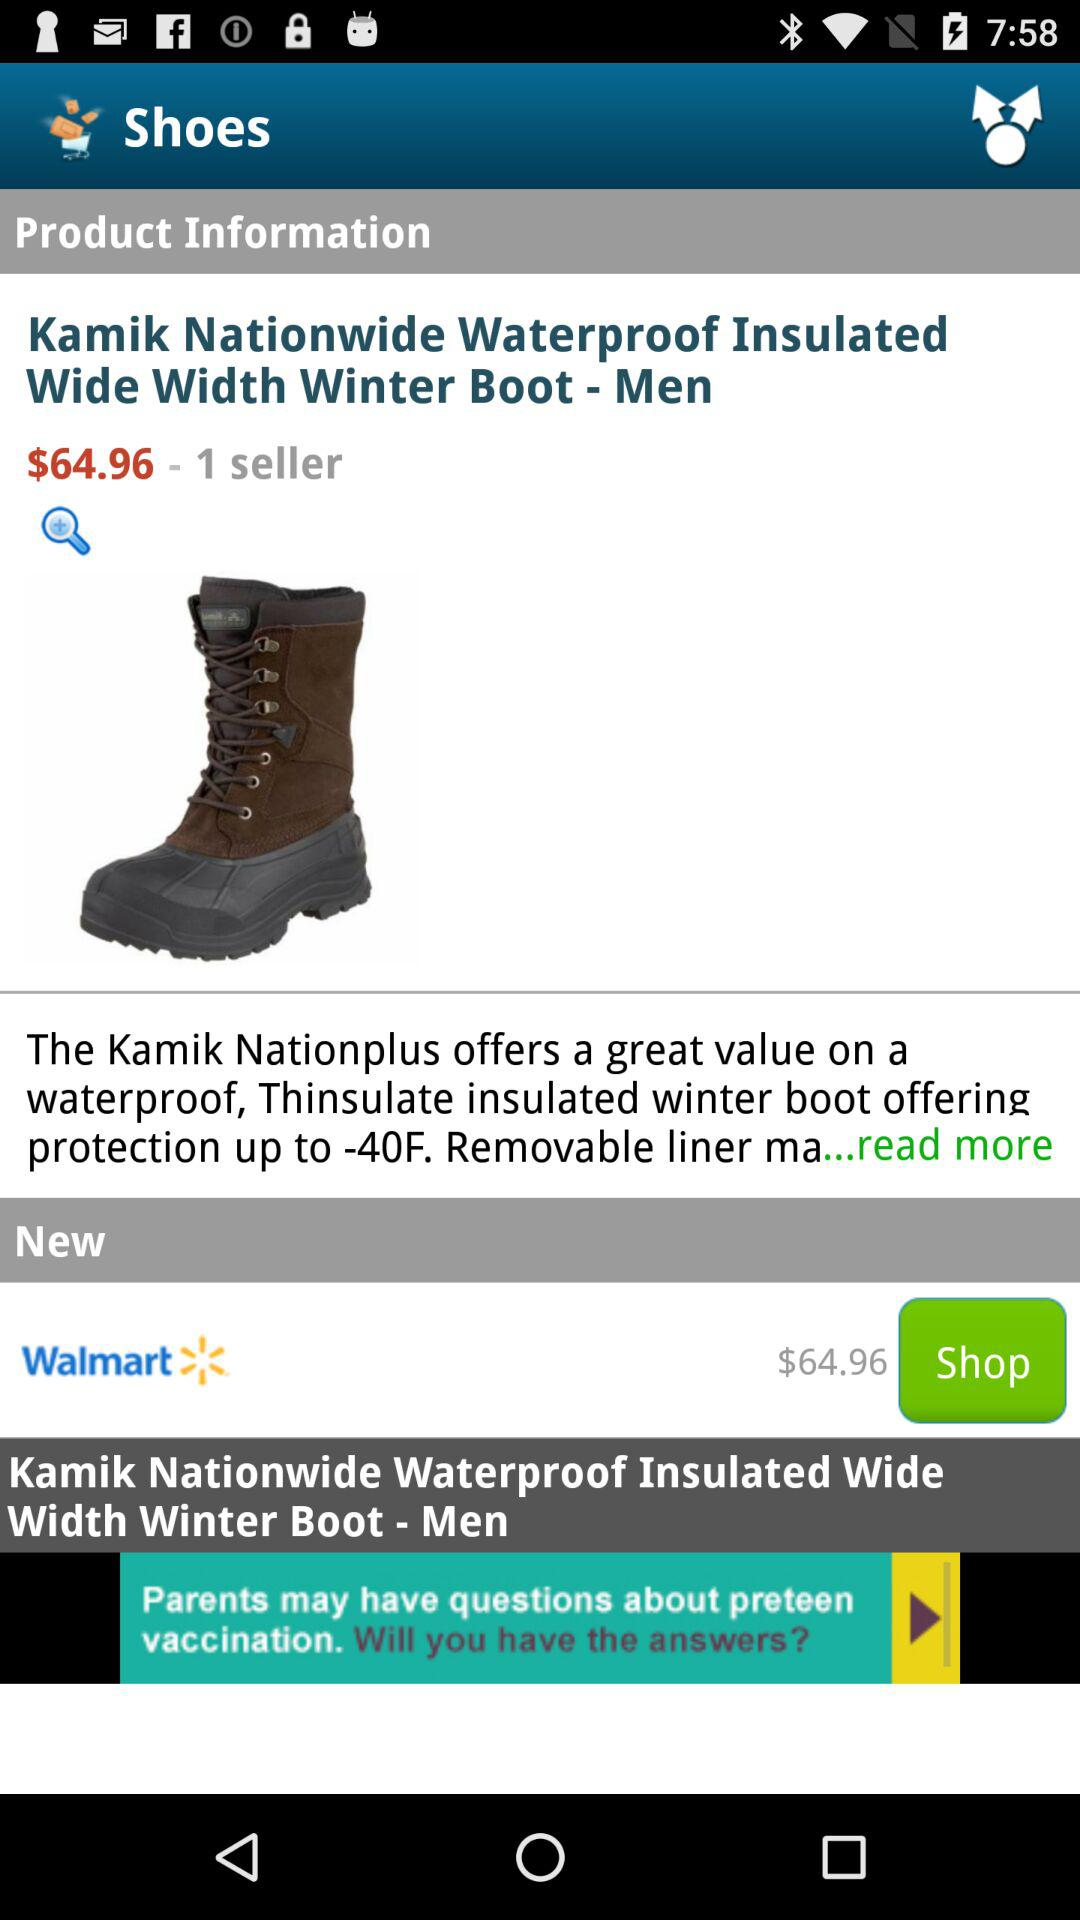How many sellers are there? There is one seller. 